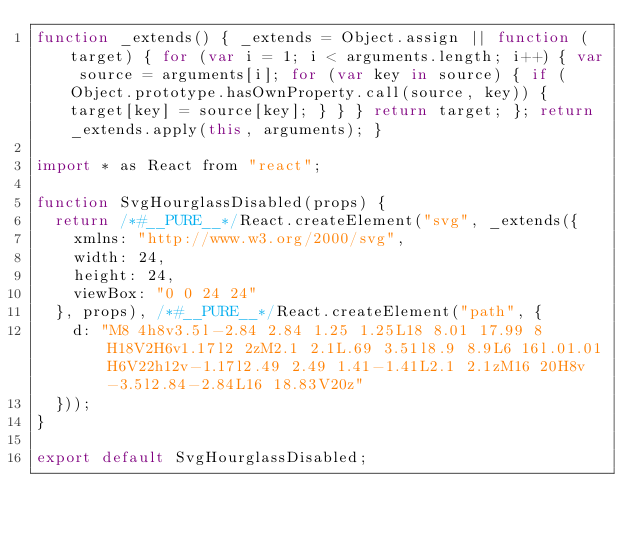Convert code to text. <code><loc_0><loc_0><loc_500><loc_500><_JavaScript_>function _extends() { _extends = Object.assign || function (target) { for (var i = 1; i < arguments.length; i++) { var source = arguments[i]; for (var key in source) { if (Object.prototype.hasOwnProperty.call(source, key)) { target[key] = source[key]; } } } return target; }; return _extends.apply(this, arguments); }

import * as React from "react";

function SvgHourglassDisabled(props) {
  return /*#__PURE__*/React.createElement("svg", _extends({
    xmlns: "http://www.w3.org/2000/svg",
    width: 24,
    height: 24,
    viewBox: "0 0 24 24"
  }, props), /*#__PURE__*/React.createElement("path", {
    d: "M8 4h8v3.5l-2.84 2.84 1.25 1.25L18 8.01 17.99 8H18V2H6v1.17l2 2zM2.1 2.1L.69 3.51l8.9 8.9L6 16l.01.01H6V22h12v-1.17l2.49 2.49 1.41-1.41L2.1 2.1zM16 20H8v-3.5l2.84-2.84L16 18.83V20z"
  }));
}

export default SvgHourglassDisabled;</code> 